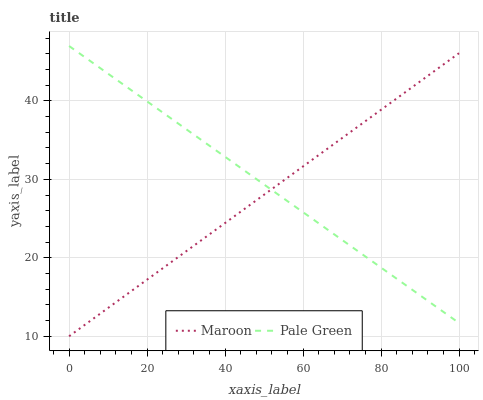Does Maroon have the minimum area under the curve?
Answer yes or no. Yes. Does Pale Green have the maximum area under the curve?
Answer yes or no. Yes. Does Maroon have the maximum area under the curve?
Answer yes or no. No. Is Maroon the smoothest?
Answer yes or no. Yes. Is Pale Green the roughest?
Answer yes or no. Yes. Is Maroon the roughest?
Answer yes or no. No. Does Maroon have the lowest value?
Answer yes or no. Yes. Does Pale Green have the highest value?
Answer yes or no. Yes. Does Maroon have the highest value?
Answer yes or no. No. Does Pale Green intersect Maroon?
Answer yes or no. Yes. Is Pale Green less than Maroon?
Answer yes or no. No. Is Pale Green greater than Maroon?
Answer yes or no. No. 